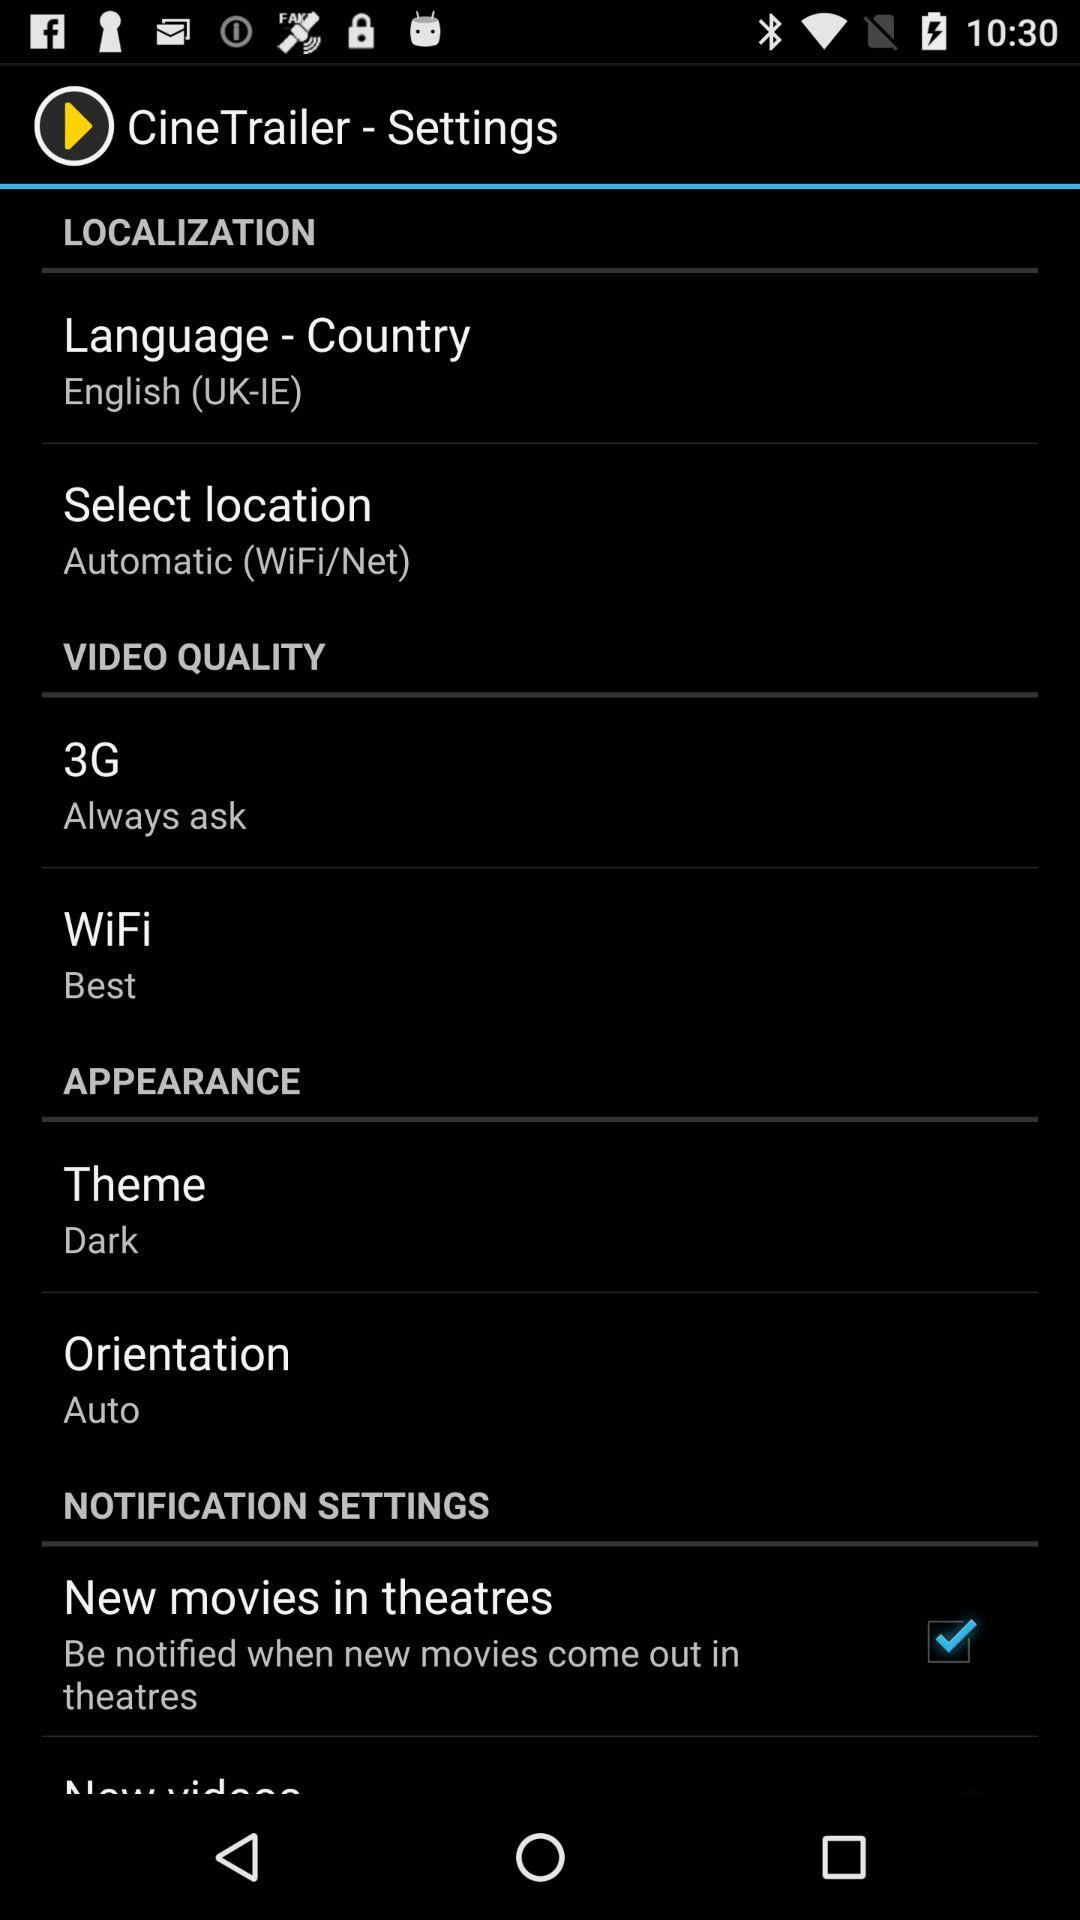What is the selected theme? The selected theme is "Dark". 